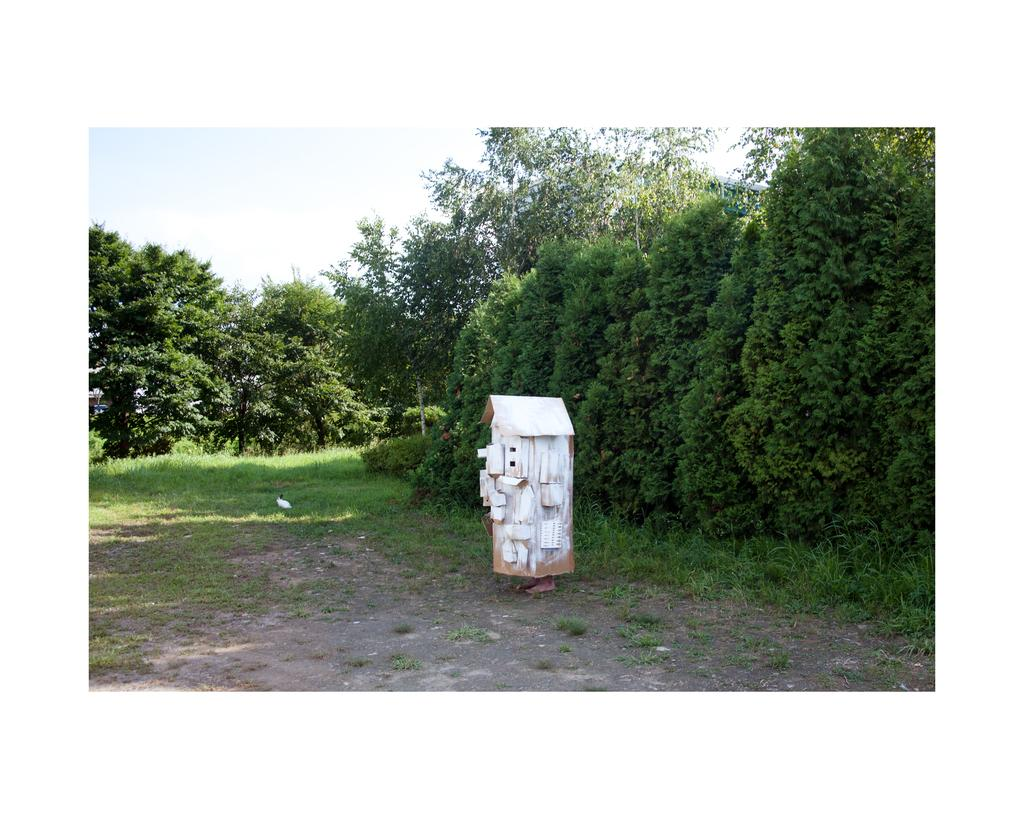What type of ground is visible in the image? There is grass ground in the image. What is the color of the object in the image? The object in the image is white. What type of vegetation can be seen in the image? There are trees in the image. What is visible in the sky in the image? There are clouds in the sky. What is the size of the calculator in the image? There is no calculator present in the image. What type of town can be seen in the image? There is no town visible in the image; it features grass ground, a white object, trees, and clouds in the sky. 